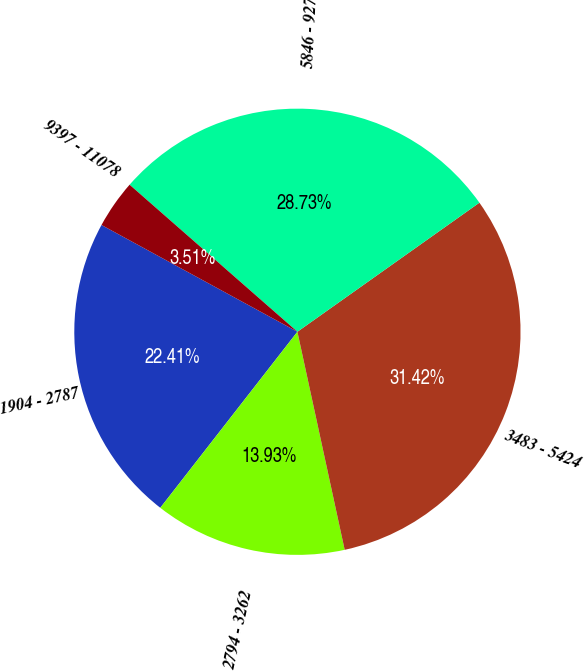Convert chart to OTSL. <chart><loc_0><loc_0><loc_500><loc_500><pie_chart><fcel>1904 - 2787<fcel>2794 - 3262<fcel>3483 - 5424<fcel>5846 - 9270<fcel>9397 - 11078<nl><fcel>22.41%<fcel>13.93%<fcel>31.42%<fcel>28.73%<fcel>3.51%<nl></chart> 